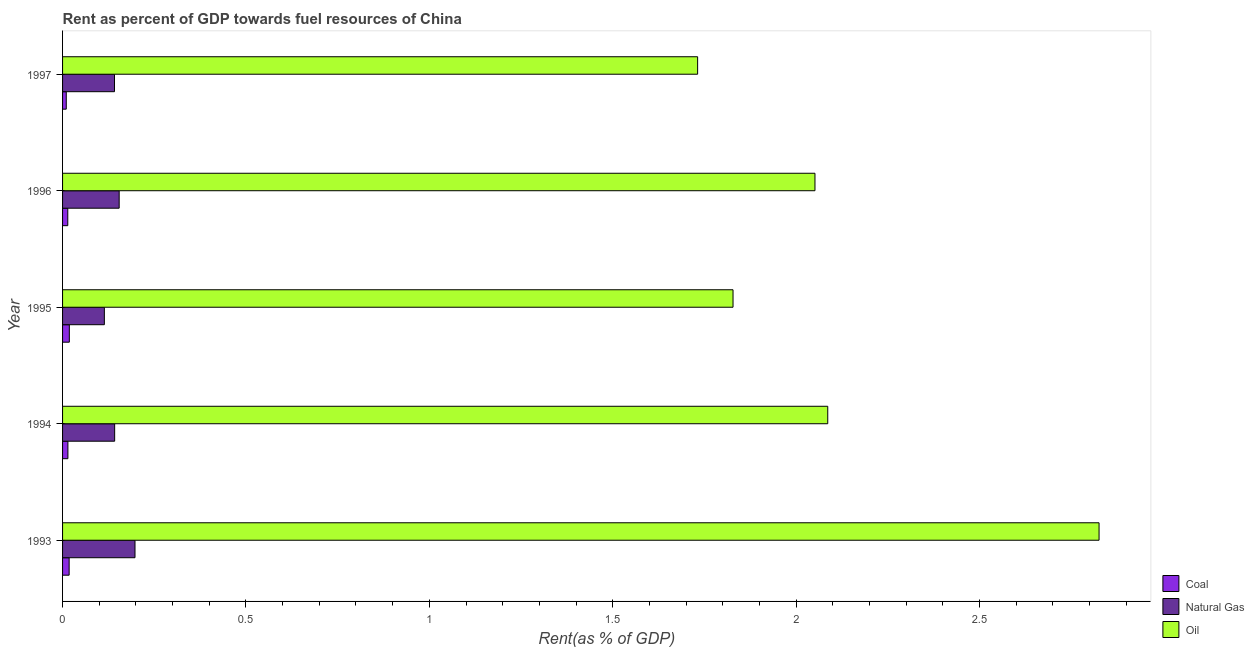How many different coloured bars are there?
Provide a short and direct response. 3. Are the number of bars per tick equal to the number of legend labels?
Provide a succinct answer. Yes. Are the number of bars on each tick of the Y-axis equal?
Offer a terse response. Yes. How many bars are there on the 5th tick from the top?
Provide a succinct answer. 3. What is the label of the 4th group of bars from the top?
Ensure brevity in your answer.  1994. What is the rent towards oil in 1995?
Offer a very short reply. 1.83. Across all years, what is the maximum rent towards oil?
Provide a succinct answer. 2.83. Across all years, what is the minimum rent towards coal?
Ensure brevity in your answer.  0.01. In which year was the rent towards oil minimum?
Offer a terse response. 1997. What is the total rent towards coal in the graph?
Ensure brevity in your answer.  0.08. What is the difference between the rent towards natural gas in 1996 and that in 1997?
Your answer should be very brief. 0.01. What is the difference between the rent towards coal in 1996 and the rent towards natural gas in 1993?
Provide a succinct answer. -0.18. What is the average rent towards oil per year?
Ensure brevity in your answer.  2.1. In the year 1995, what is the difference between the rent towards coal and rent towards oil?
Offer a terse response. -1.81. Is the difference between the rent towards coal in 1995 and 1997 greater than the difference between the rent towards oil in 1995 and 1997?
Ensure brevity in your answer.  No. What is the difference between the highest and the second highest rent towards coal?
Ensure brevity in your answer.  0. What is the difference between the highest and the lowest rent towards natural gas?
Ensure brevity in your answer.  0.08. What does the 3rd bar from the top in 1993 represents?
Your answer should be compact. Coal. What does the 1st bar from the bottom in 1996 represents?
Make the answer very short. Coal. Are all the bars in the graph horizontal?
Provide a succinct answer. Yes. Does the graph contain any zero values?
Give a very brief answer. No. Does the graph contain grids?
Provide a succinct answer. No. Where does the legend appear in the graph?
Your answer should be compact. Bottom right. How many legend labels are there?
Keep it short and to the point. 3. How are the legend labels stacked?
Keep it short and to the point. Vertical. What is the title of the graph?
Make the answer very short. Rent as percent of GDP towards fuel resources of China. What is the label or title of the X-axis?
Give a very brief answer. Rent(as % of GDP). What is the label or title of the Y-axis?
Provide a succinct answer. Year. What is the Rent(as % of GDP) in Coal in 1993?
Your answer should be compact. 0.02. What is the Rent(as % of GDP) in Natural Gas in 1993?
Make the answer very short. 0.2. What is the Rent(as % of GDP) in Oil in 1993?
Offer a terse response. 2.83. What is the Rent(as % of GDP) in Coal in 1994?
Offer a terse response. 0.01. What is the Rent(as % of GDP) in Natural Gas in 1994?
Offer a very short reply. 0.14. What is the Rent(as % of GDP) of Oil in 1994?
Provide a short and direct response. 2.09. What is the Rent(as % of GDP) in Coal in 1995?
Your response must be concise. 0.02. What is the Rent(as % of GDP) of Natural Gas in 1995?
Offer a terse response. 0.11. What is the Rent(as % of GDP) in Oil in 1995?
Your response must be concise. 1.83. What is the Rent(as % of GDP) of Coal in 1996?
Your answer should be very brief. 0.01. What is the Rent(as % of GDP) of Natural Gas in 1996?
Offer a very short reply. 0.15. What is the Rent(as % of GDP) of Oil in 1996?
Give a very brief answer. 2.05. What is the Rent(as % of GDP) of Coal in 1997?
Provide a short and direct response. 0.01. What is the Rent(as % of GDP) of Natural Gas in 1997?
Your response must be concise. 0.14. What is the Rent(as % of GDP) of Oil in 1997?
Your answer should be compact. 1.73. Across all years, what is the maximum Rent(as % of GDP) of Coal?
Offer a terse response. 0.02. Across all years, what is the maximum Rent(as % of GDP) in Natural Gas?
Your response must be concise. 0.2. Across all years, what is the maximum Rent(as % of GDP) of Oil?
Ensure brevity in your answer.  2.83. Across all years, what is the minimum Rent(as % of GDP) in Coal?
Ensure brevity in your answer.  0.01. Across all years, what is the minimum Rent(as % of GDP) in Natural Gas?
Provide a short and direct response. 0.11. Across all years, what is the minimum Rent(as % of GDP) in Oil?
Ensure brevity in your answer.  1.73. What is the total Rent(as % of GDP) in Coal in the graph?
Provide a succinct answer. 0.08. What is the total Rent(as % of GDP) of Natural Gas in the graph?
Your answer should be compact. 0.75. What is the total Rent(as % of GDP) of Oil in the graph?
Offer a very short reply. 10.52. What is the difference between the Rent(as % of GDP) of Coal in 1993 and that in 1994?
Make the answer very short. 0. What is the difference between the Rent(as % of GDP) in Natural Gas in 1993 and that in 1994?
Your answer should be very brief. 0.06. What is the difference between the Rent(as % of GDP) in Oil in 1993 and that in 1994?
Give a very brief answer. 0.74. What is the difference between the Rent(as % of GDP) in Coal in 1993 and that in 1995?
Offer a very short reply. -0. What is the difference between the Rent(as % of GDP) in Natural Gas in 1993 and that in 1995?
Ensure brevity in your answer.  0.08. What is the difference between the Rent(as % of GDP) in Oil in 1993 and that in 1995?
Offer a very short reply. 1. What is the difference between the Rent(as % of GDP) in Coal in 1993 and that in 1996?
Provide a short and direct response. 0. What is the difference between the Rent(as % of GDP) in Natural Gas in 1993 and that in 1996?
Your answer should be compact. 0.04. What is the difference between the Rent(as % of GDP) of Oil in 1993 and that in 1996?
Provide a short and direct response. 0.77. What is the difference between the Rent(as % of GDP) in Coal in 1993 and that in 1997?
Your answer should be compact. 0.01. What is the difference between the Rent(as % of GDP) of Natural Gas in 1993 and that in 1997?
Give a very brief answer. 0.06. What is the difference between the Rent(as % of GDP) of Oil in 1993 and that in 1997?
Your answer should be very brief. 1.09. What is the difference between the Rent(as % of GDP) in Coal in 1994 and that in 1995?
Keep it short and to the point. -0. What is the difference between the Rent(as % of GDP) in Natural Gas in 1994 and that in 1995?
Keep it short and to the point. 0.03. What is the difference between the Rent(as % of GDP) of Oil in 1994 and that in 1995?
Provide a short and direct response. 0.26. What is the difference between the Rent(as % of GDP) of Natural Gas in 1994 and that in 1996?
Make the answer very short. -0.01. What is the difference between the Rent(as % of GDP) in Oil in 1994 and that in 1996?
Your answer should be compact. 0.03. What is the difference between the Rent(as % of GDP) of Coal in 1994 and that in 1997?
Offer a very short reply. 0. What is the difference between the Rent(as % of GDP) of Natural Gas in 1994 and that in 1997?
Your answer should be very brief. 0. What is the difference between the Rent(as % of GDP) of Oil in 1994 and that in 1997?
Your answer should be very brief. 0.35. What is the difference between the Rent(as % of GDP) of Coal in 1995 and that in 1996?
Your answer should be compact. 0. What is the difference between the Rent(as % of GDP) in Natural Gas in 1995 and that in 1996?
Your answer should be very brief. -0.04. What is the difference between the Rent(as % of GDP) in Oil in 1995 and that in 1996?
Offer a very short reply. -0.22. What is the difference between the Rent(as % of GDP) in Coal in 1995 and that in 1997?
Make the answer very short. 0.01. What is the difference between the Rent(as % of GDP) of Natural Gas in 1995 and that in 1997?
Offer a terse response. -0.03. What is the difference between the Rent(as % of GDP) in Oil in 1995 and that in 1997?
Make the answer very short. 0.1. What is the difference between the Rent(as % of GDP) of Coal in 1996 and that in 1997?
Your answer should be very brief. 0. What is the difference between the Rent(as % of GDP) of Natural Gas in 1996 and that in 1997?
Your response must be concise. 0.01. What is the difference between the Rent(as % of GDP) in Oil in 1996 and that in 1997?
Give a very brief answer. 0.32. What is the difference between the Rent(as % of GDP) of Coal in 1993 and the Rent(as % of GDP) of Natural Gas in 1994?
Provide a succinct answer. -0.12. What is the difference between the Rent(as % of GDP) in Coal in 1993 and the Rent(as % of GDP) in Oil in 1994?
Keep it short and to the point. -2.07. What is the difference between the Rent(as % of GDP) in Natural Gas in 1993 and the Rent(as % of GDP) in Oil in 1994?
Offer a very short reply. -1.89. What is the difference between the Rent(as % of GDP) in Coal in 1993 and the Rent(as % of GDP) in Natural Gas in 1995?
Ensure brevity in your answer.  -0.1. What is the difference between the Rent(as % of GDP) of Coal in 1993 and the Rent(as % of GDP) of Oil in 1995?
Your answer should be very brief. -1.81. What is the difference between the Rent(as % of GDP) in Natural Gas in 1993 and the Rent(as % of GDP) in Oil in 1995?
Keep it short and to the point. -1.63. What is the difference between the Rent(as % of GDP) of Coal in 1993 and the Rent(as % of GDP) of Natural Gas in 1996?
Your answer should be compact. -0.14. What is the difference between the Rent(as % of GDP) of Coal in 1993 and the Rent(as % of GDP) of Oil in 1996?
Make the answer very short. -2.03. What is the difference between the Rent(as % of GDP) of Natural Gas in 1993 and the Rent(as % of GDP) of Oil in 1996?
Your response must be concise. -1.85. What is the difference between the Rent(as % of GDP) in Coal in 1993 and the Rent(as % of GDP) in Natural Gas in 1997?
Your response must be concise. -0.12. What is the difference between the Rent(as % of GDP) in Coal in 1993 and the Rent(as % of GDP) in Oil in 1997?
Your answer should be compact. -1.71. What is the difference between the Rent(as % of GDP) of Natural Gas in 1993 and the Rent(as % of GDP) of Oil in 1997?
Provide a short and direct response. -1.53. What is the difference between the Rent(as % of GDP) in Coal in 1994 and the Rent(as % of GDP) in Natural Gas in 1995?
Your answer should be compact. -0.1. What is the difference between the Rent(as % of GDP) of Coal in 1994 and the Rent(as % of GDP) of Oil in 1995?
Your answer should be very brief. -1.81. What is the difference between the Rent(as % of GDP) in Natural Gas in 1994 and the Rent(as % of GDP) in Oil in 1995?
Ensure brevity in your answer.  -1.69. What is the difference between the Rent(as % of GDP) in Coal in 1994 and the Rent(as % of GDP) in Natural Gas in 1996?
Your response must be concise. -0.14. What is the difference between the Rent(as % of GDP) in Coal in 1994 and the Rent(as % of GDP) in Oil in 1996?
Provide a succinct answer. -2.04. What is the difference between the Rent(as % of GDP) in Natural Gas in 1994 and the Rent(as % of GDP) in Oil in 1996?
Offer a very short reply. -1.91. What is the difference between the Rent(as % of GDP) in Coal in 1994 and the Rent(as % of GDP) in Natural Gas in 1997?
Give a very brief answer. -0.13. What is the difference between the Rent(as % of GDP) of Coal in 1994 and the Rent(as % of GDP) of Oil in 1997?
Offer a very short reply. -1.72. What is the difference between the Rent(as % of GDP) of Natural Gas in 1994 and the Rent(as % of GDP) of Oil in 1997?
Give a very brief answer. -1.59. What is the difference between the Rent(as % of GDP) in Coal in 1995 and the Rent(as % of GDP) in Natural Gas in 1996?
Ensure brevity in your answer.  -0.14. What is the difference between the Rent(as % of GDP) of Coal in 1995 and the Rent(as % of GDP) of Oil in 1996?
Make the answer very short. -2.03. What is the difference between the Rent(as % of GDP) in Natural Gas in 1995 and the Rent(as % of GDP) in Oil in 1996?
Offer a terse response. -1.94. What is the difference between the Rent(as % of GDP) in Coal in 1995 and the Rent(as % of GDP) in Natural Gas in 1997?
Provide a short and direct response. -0.12. What is the difference between the Rent(as % of GDP) in Coal in 1995 and the Rent(as % of GDP) in Oil in 1997?
Provide a succinct answer. -1.71. What is the difference between the Rent(as % of GDP) of Natural Gas in 1995 and the Rent(as % of GDP) of Oil in 1997?
Ensure brevity in your answer.  -1.62. What is the difference between the Rent(as % of GDP) of Coal in 1996 and the Rent(as % of GDP) of Natural Gas in 1997?
Keep it short and to the point. -0.13. What is the difference between the Rent(as % of GDP) of Coal in 1996 and the Rent(as % of GDP) of Oil in 1997?
Provide a short and direct response. -1.72. What is the difference between the Rent(as % of GDP) in Natural Gas in 1996 and the Rent(as % of GDP) in Oil in 1997?
Ensure brevity in your answer.  -1.58. What is the average Rent(as % of GDP) of Coal per year?
Provide a succinct answer. 0.01. What is the average Rent(as % of GDP) of Natural Gas per year?
Provide a short and direct response. 0.15. What is the average Rent(as % of GDP) of Oil per year?
Offer a terse response. 2.1. In the year 1993, what is the difference between the Rent(as % of GDP) of Coal and Rent(as % of GDP) of Natural Gas?
Provide a succinct answer. -0.18. In the year 1993, what is the difference between the Rent(as % of GDP) of Coal and Rent(as % of GDP) of Oil?
Ensure brevity in your answer.  -2.81. In the year 1993, what is the difference between the Rent(as % of GDP) in Natural Gas and Rent(as % of GDP) in Oil?
Your answer should be compact. -2.63. In the year 1994, what is the difference between the Rent(as % of GDP) of Coal and Rent(as % of GDP) of Natural Gas?
Offer a terse response. -0.13. In the year 1994, what is the difference between the Rent(as % of GDP) of Coal and Rent(as % of GDP) of Oil?
Your answer should be compact. -2.07. In the year 1994, what is the difference between the Rent(as % of GDP) in Natural Gas and Rent(as % of GDP) in Oil?
Provide a short and direct response. -1.94. In the year 1995, what is the difference between the Rent(as % of GDP) in Coal and Rent(as % of GDP) in Natural Gas?
Keep it short and to the point. -0.1. In the year 1995, what is the difference between the Rent(as % of GDP) of Coal and Rent(as % of GDP) of Oil?
Your answer should be compact. -1.81. In the year 1995, what is the difference between the Rent(as % of GDP) of Natural Gas and Rent(as % of GDP) of Oil?
Give a very brief answer. -1.71. In the year 1996, what is the difference between the Rent(as % of GDP) of Coal and Rent(as % of GDP) of Natural Gas?
Keep it short and to the point. -0.14. In the year 1996, what is the difference between the Rent(as % of GDP) in Coal and Rent(as % of GDP) in Oil?
Give a very brief answer. -2.04. In the year 1996, what is the difference between the Rent(as % of GDP) of Natural Gas and Rent(as % of GDP) of Oil?
Your answer should be very brief. -1.9. In the year 1997, what is the difference between the Rent(as % of GDP) of Coal and Rent(as % of GDP) of Natural Gas?
Keep it short and to the point. -0.13. In the year 1997, what is the difference between the Rent(as % of GDP) in Coal and Rent(as % of GDP) in Oil?
Your answer should be compact. -1.72. In the year 1997, what is the difference between the Rent(as % of GDP) of Natural Gas and Rent(as % of GDP) of Oil?
Provide a short and direct response. -1.59. What is the ratio of the Rent(as % of GDP) in Coal in 1993 to that in 1994?
Offer a terse response. 1.23. What is the ratio of the Rent(as % of GDP) in Natural Gas in 1993 to that in 1994?
Provide a succinct answer. 1.39. What is the ratio of the Rent(as % of GDP) of Oil in 1993 to that in 1994?
Provide a succinct answer. 1.35. What is the ratio of the Rent(as % of GDP) in Coal in 1993 to that in 1995?
Offer a terse response. 0.97. What is the ratio of the Rent(as % of GDP) of Natural Gas in 1993 to that in 1995?
Your answer should be very brief. 1.73. What is the ratio of the Rent(as % of GDP) in Oil in 1993 to that in 1995?
Your answer should be very brief. 1.55. What is the ratio of the Rent(as % of GDP) of Coal in 1993 to that in 1996?
Provide a short and direct response. 1.26. What is the ratio of the Rent(as % of GDP) in Natural Gas in 1993 to that in 1996?
Offer a terse response. 1.28. What is the ratio of the Rent(as % of GDP) in Oil in 1993 to that in 1996?
Provide a short and direct response. 1.38. What is the ratio of the Rent(as % of GDP) in Coal in 1993 to that in 1997?
Provide a short and direct response. 1.78. What is the ratio of the Rent(as % of GDP) in Natural Gas in 1993 to that in 1997?
Your answer should be very brief. 1.39. What is the ratio of the Rent(as % of GDP) in Oil in 1993 to that in 1997?
Your response must be concise. 1.63. What is the ratio of the Rent(as % of GDP) of Coal in 1994 to that in 1995?
Make the answer very short. 0.79. What is the ratio of the Rent(as % of GDP) in Natural Gas in 1994 to that in 1995?
Provide a short and direct response. 1.25. What is the ratio of the Rent(as % of GDP) in Oil in 1994 to that in 1995?
Provide a succinct answer. 1.14. What is the ratio of the Rent(as % of GDP) in Coal in 1994 to that in 1996?
Provide a short and direct response. 1.02. What is the ratio of the Rent(as % of GDP) of Natural Gas in 1994 to that in 1996?
Your response must be concise. 0.92. What is the ratio of the Rent(as % of GDP) in Coal in 1994 to that in 1997?
Give a very brief answer. 1.44. What is the ratio of the Rent(as % of GDP) of Natural Gas in 1994 to that in 1997?
Your answer should be compact. 1. What is the ratio of the Rent(as % of GDP) in Oil in 1994 to that in 1997?
Give a very brief answer. 1.2. What is the ratio of the Rent(as % of GDP) of Coal in 1995 to that in 1996?
Provide a short and direct response. 1.3. What is the ratio of the Rent(as % of GDP) of Natural Gas in 1995 to that in 1996?
Offer a very short reply. 0.74. What is the ratio of the Rent(as % of GDP) in Oil in 1995 to that in 1996?
Provide a short and direct response. 0.89. What is the ratio of the Rent(as % of GDP) of Coal in 1995 to that in 1997?
Offer a terse response. 1.83. What is the ratio of the Rent(as % of GDP) of Natural Gas in 1995 to that in 1997?
Make the answer very short. 0.8. What is the ratio of the Rent(as % of GDP) in Oil in 1995 to that in 1997?
Your answer should be compact. 1.06. What is the ratio of the Rent(as % of GDP) of Coal in 1996 to that in 1997?
Keep it short and to the point. 1.41. What is the ratio of the Rent(as % of GDP) of Natural Gas in 1996 to that in 1997?
Your response must be concise. 1.09. What is the ratio of the Rent(as % of GDP) of Oil in 1996 to that in 1997?
Your answer should be compact. 1.18. What is the difference between the highest and the second highest Rent(as % of GDP) of Natural Gas?
Keep it short and to the point. 0.04. What is the difference between the highest and the second highest Rent(as % of GDP) in Oil?
Make the answer very short. 0.74. What is the difference between the highest and the lowest Rent(as % of GDP) in Coal?
Your answer should be very brief. 0.01. What is the difference between the highest and the lowest Rent(as % of GDP) of Natural Gas?
Offer a terse response. 0.08. What is the difference between the highest and the lowest Rent(as % of GDP) of Oil?
Your response must be concise. 1.09. 